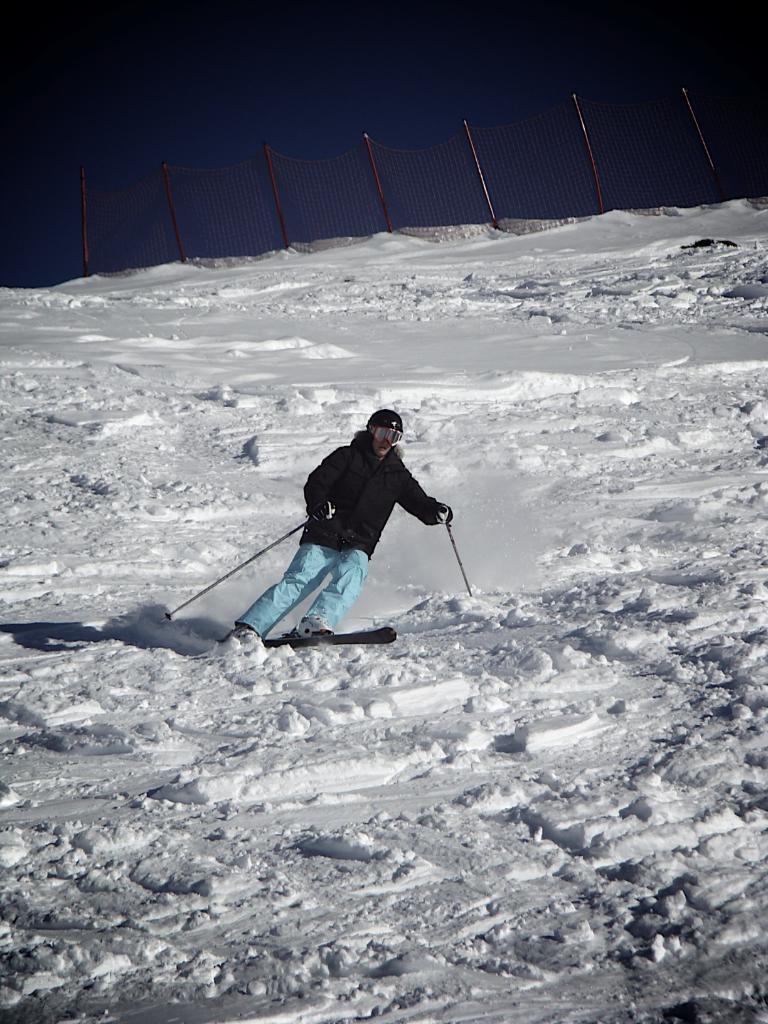Describe this image in one or two sentences. In the image I can see a person who is wearing the helmet and holding the sticks and skimboarding on the snow floor. 